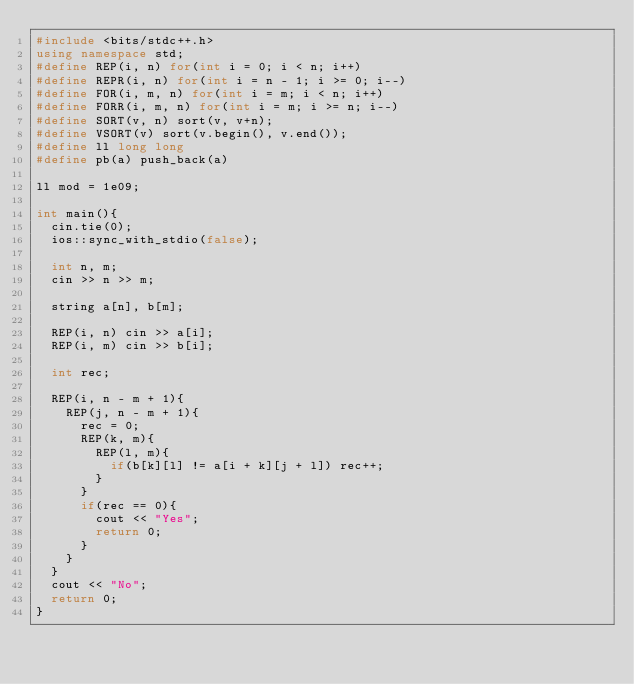<code> <loc_0><loc_0><loc_500><loc_500><_C++_>#include <bits/stdc++.h>
using namespace std;
#define REP(i, n) for(int i = 0; i < n; i++)
#define REPR(i, n) for(int i = n - 1; i >= 0; i--)
#define FOR(i, m, n) for(int i = m; i < n; i++)
#define FORR(i, m, n) for(int i = m; i >= n; i--)
#define SORT(v, n) sort(v, v+n);
#define VSORT(v) sort(v.begin(), v.end());
#define ll long long
#define pb(a) push_back(a)

ll mod = 1e09;

int main(){
  cin.tie(0);
  ios::sync_with_stdio(false);

  int n, m;
  cin >> n >> m;

  string a[n], b[m];

  REP(i, n) cin >> a[i];
  REP(i, m) cin >> b[i];

  int rec;

  REP(i, n - m + 1){
    REP(j, n - m + 1){
      rec = 0;
      REP(k, m){
        REP(l, m){
          if(b[k][l] != a[i + k][j + l]) rec++;
        }
      }
      if(rec == 0){
        cout << "Yes";
        return 0;
      }
    }
  }
  cout << "No";
  return 0;
}
</code> 